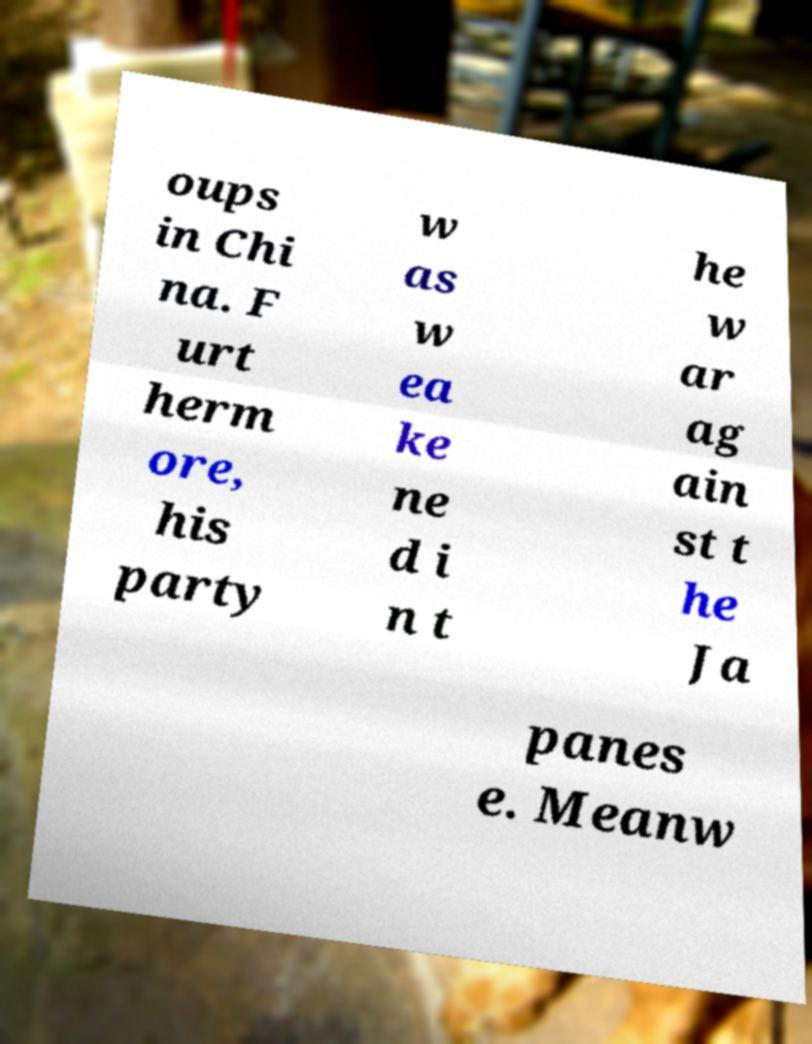Could you extract and type out the text from this image? oups in Chi na. F urt herm ore, his party w as w ea ke ne d i n t he w ar ag ain st t he Ja panes e. Meanw 